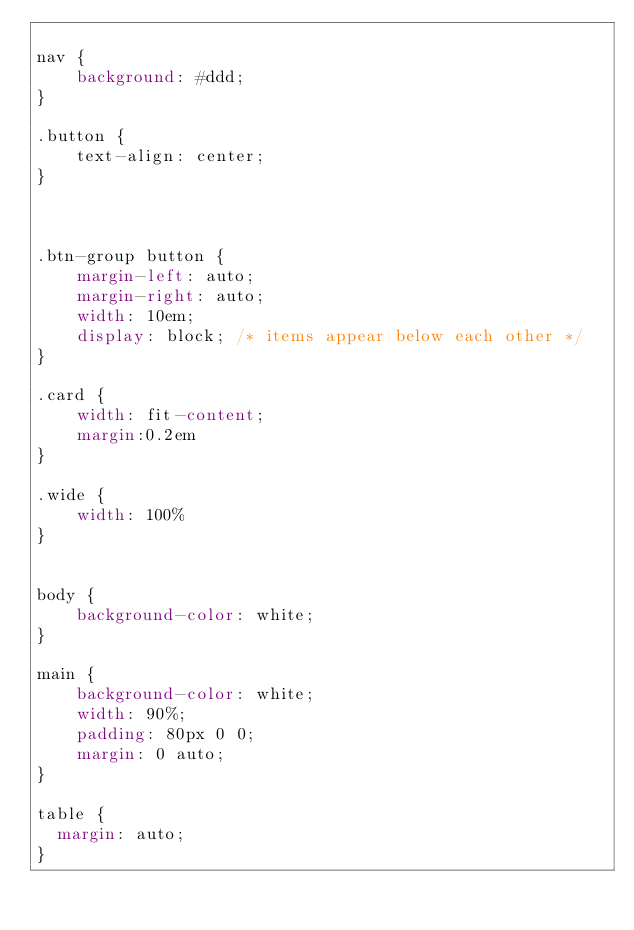Convert code to text. <code><loc_0><loc_0><loc_500><loc_500><_CSS_>
nav {
    background: #ddd;
}

.button {
    text-align: center;
}



.btn-group button {
    margin-left: auto;
    margin-right: auto;
    width: 10em;
    display: block; /* items appear below each other */
}

.card {
    width: fit-content;
    margin:0.2em
}

.wide {
    width: 100%
}


body {
    background-color: white;
}

main {
    background-color: white;
    width: 90%;
    padding: 80px 0 0;
    margin: 0 auto;
}

table {
  margin: auto;
}</code> 